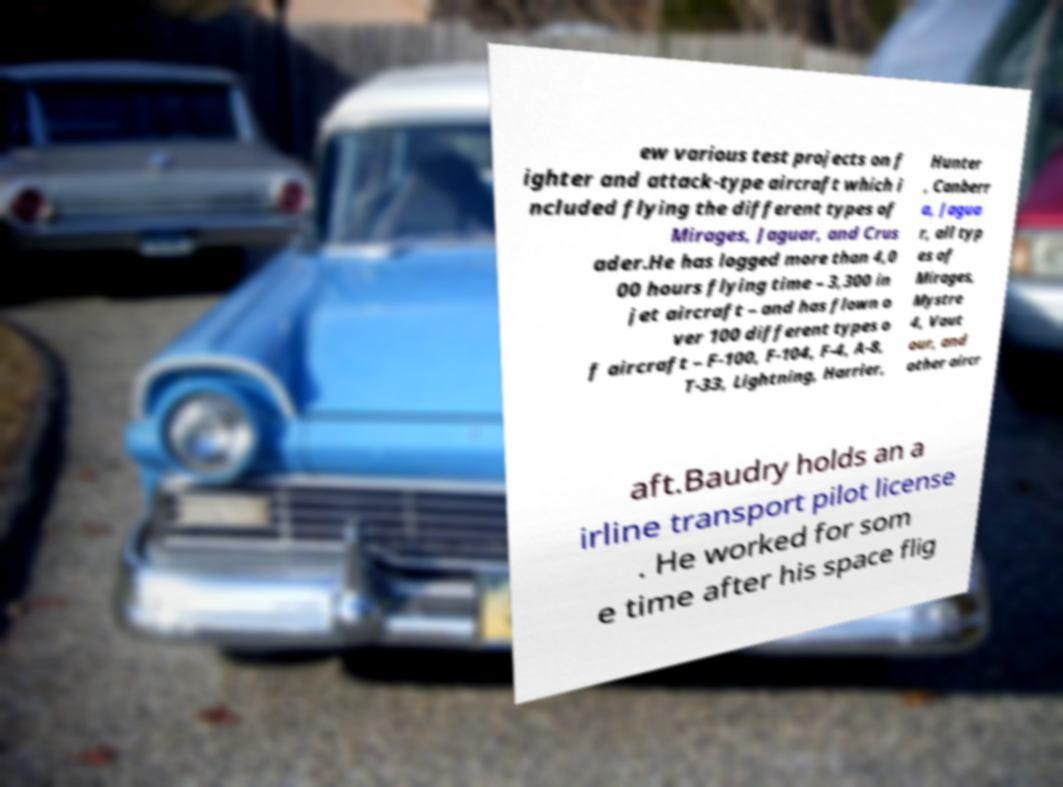I need the written content from this picture converted into text. Can you do that? ew various test projects on f ighter and attack-type aircraft which i ncluded flying the different types of Mirages, Jaguar, and Crus ader.He has logged more than 4,0 00 hours flying time – 3,300 in jet aircraft – and has flown o ver 100 different types o f aircraft – F-100, F-104, F-4, A-8, T-33, Lightning, Harrier, Hunter , Canberr a, Jagua r, all typ es of Mirages, Mystre 4, Vaut our, and other aircr aft.Baudry holds an a irline transport pilot license . He worked for som e time after his space flig 